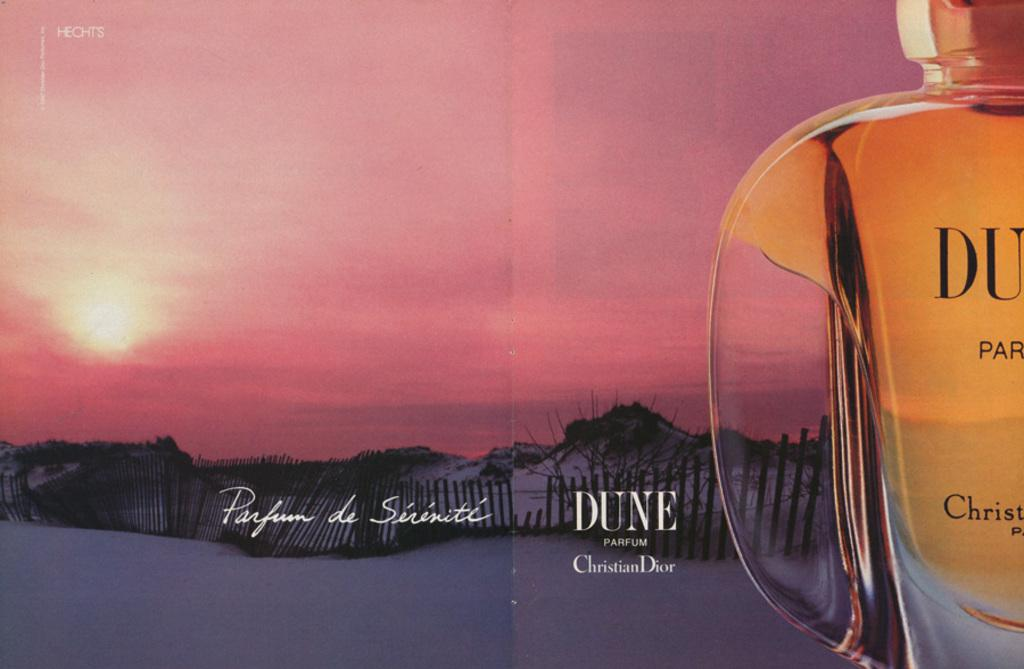Provide a one-sentence caption for the provided image. an ad for a perfum called DUNE by Christion Dior. 